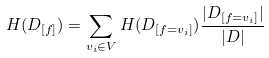Convert formula to latex. <formula><loc_0><loc_0><loc_500><loc_500>H ( D _ { [ f ] } ) = \sum _ { v _ { i } \in V } H ( D _ { [ f = v _ { i } ] } ) \frac { | D _ { [ f = v _ { i } ] } | } { | D | }</formula> 